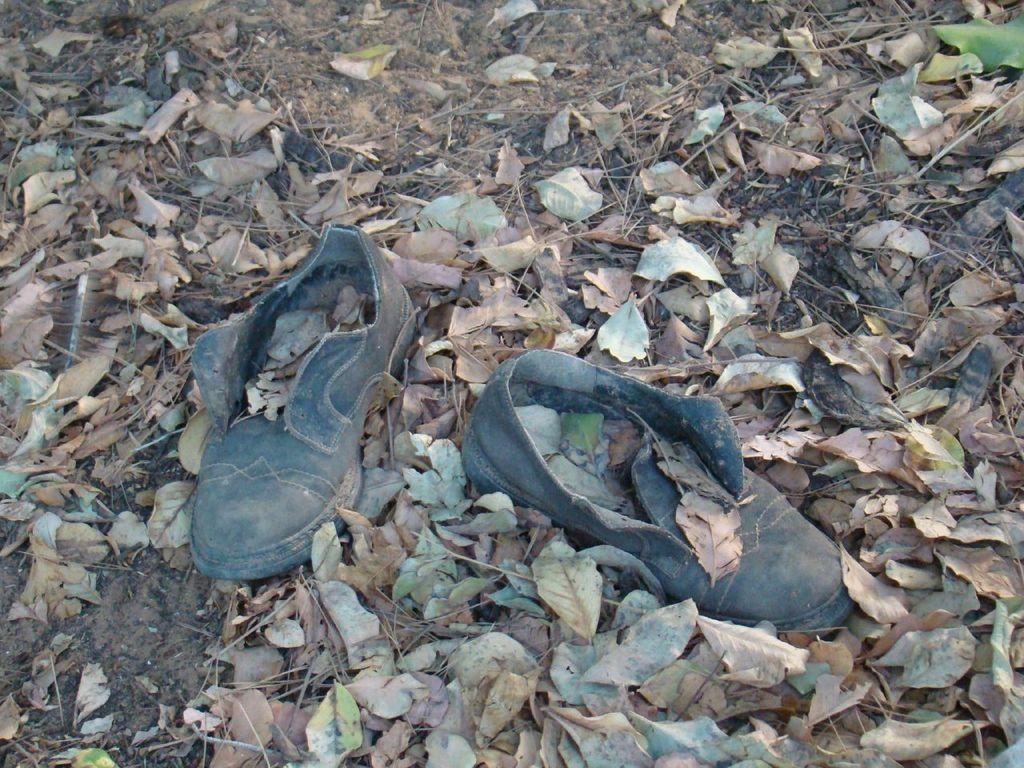What is the main subject in the center of the image? There is a pair of shoes in the center of the image. What type of natural debris can be seen in the image? There are dry leaves in the image. What type of damage is visible in the image? There is a scrape visible in the image. What type of terrain is present in the image? Sand is present in the image. Where is the lunchroom located in the image? There is no lunchroom present in the image. 